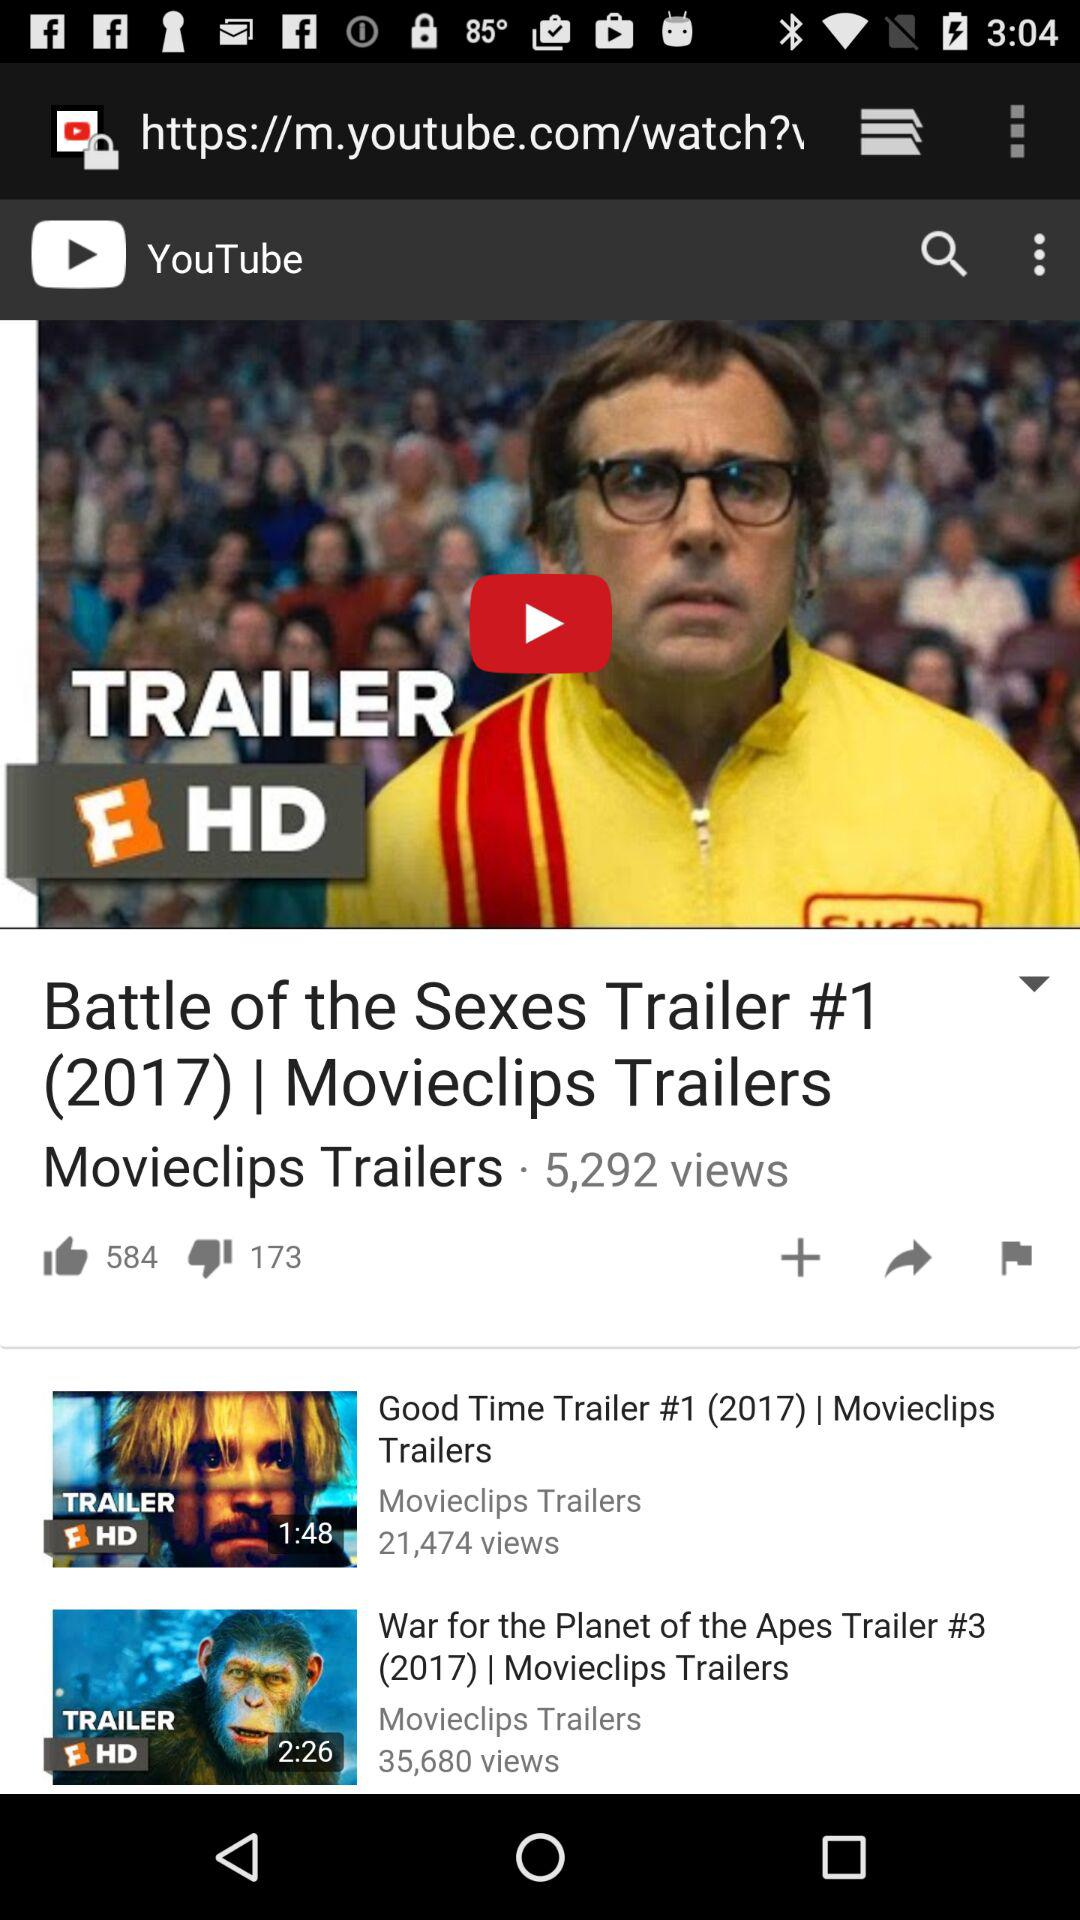Can we share video?
When the provided information is insufficient, respond with <no answer>. <no answer> 